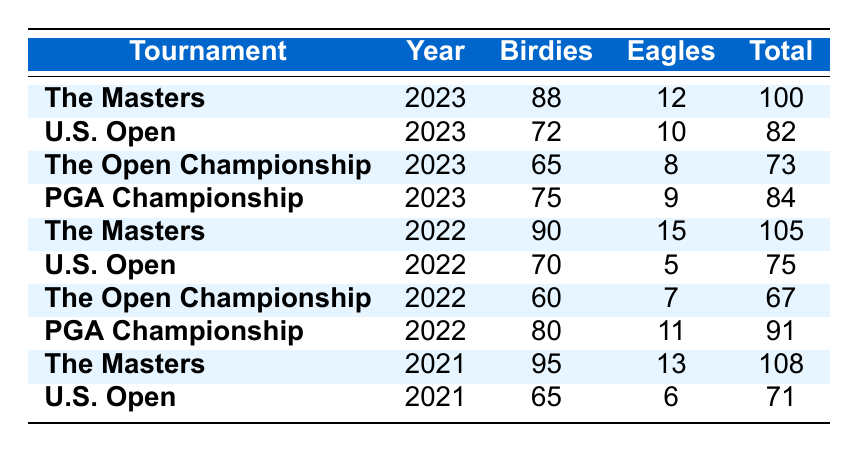What's the total number of birdies made in The Masters 2023? From the table, in The Masters 2023, the number of birdies is directly stated as 88.
Answer: 88 Which tournament had the highest number of eagles in 2022? Looking through the eagles column for the year 2022, the highest value is 15, which is associated with The Masters.
Answer: The Masters What is the average number of birdies made across all tournaments in 2023? To find the average, we sum the birdies for 2023: 88 + 72 + 65 + 75 = 300. There are 4 tournaments, so the average is 300 / 4 = 75.
Answer: 75 Did The Open Championship 2021 have more eagles than the U.S. Open 2021? In the table, The Open Championship 2021 had 0 eagles (not listed), while the U.S. Open 2021 had 6 eagles. Therefore, it is false that The Open Championship had more.
Answer: No What was the total number of birdies and eagles made in the PGA Championship 2022? The table shows that for the PGA Championship in 2022, birdies are 80 and eagles are 11. Adding these gives 80 + 11 = 91.
Answer: 91 Which tournament had the lowest total of birdies and eagles combined in 2023? For 2023, the total of birdies and eagles for each tournament can be calculated: The Masters (100), U.S. Open (82), The Open Championship (73), and PGA Championship (84). The lowest total is for The Open Championship with 73.
Answer: The Open Championship How many more birdies were made in The Masters 2021 than in U.S. Open 2021? The Masters 2021 had 95 birdies and the U.S. Open 2021 had 65. The difference is 95 - 65 = 30.
Answer: 30 What is the total number of birdies across all tournaments in 2022? Summing up the birdies for 2022: 90 (The Masters) + 70 (U.S. Open) + 60 (The Open Championship) + 80 (PGA Championship) gives 90 + 70 + 60 + 80 = 300.
Answer: 300 